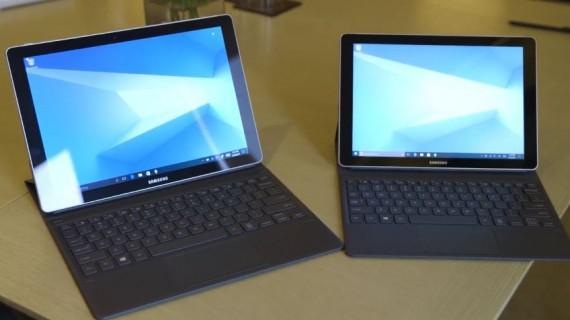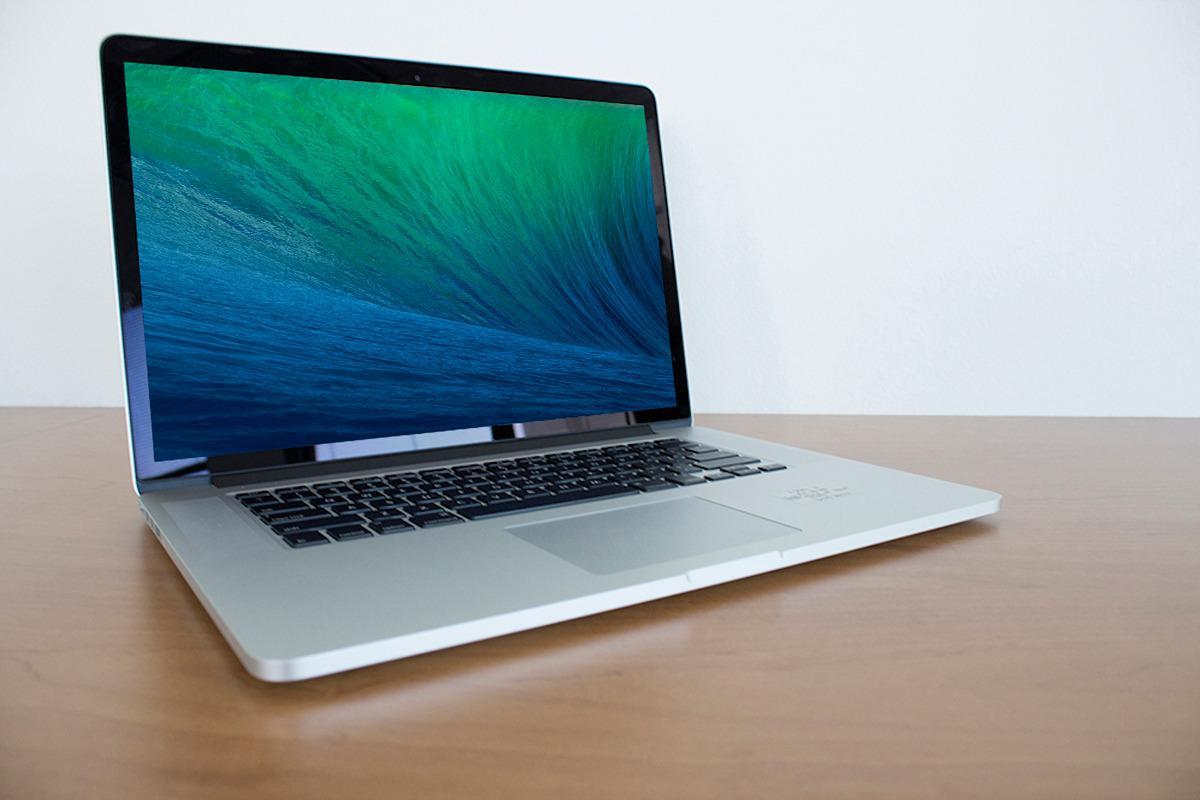The first image is the image on the left, the second image is the image on the right. Analyze the images presented: Is the assertion "The left and right image contains the same number of laptops." valid? Answer yes or no. No. The first image is the image on the left, the second image is the image on the right. For the images shown, is this caption "One image contains twice as many laptops as the other image, and the other image features a rightward-facing laptop with a blue-and-green wave on its screen." true? Answer yes or no. Yes. 